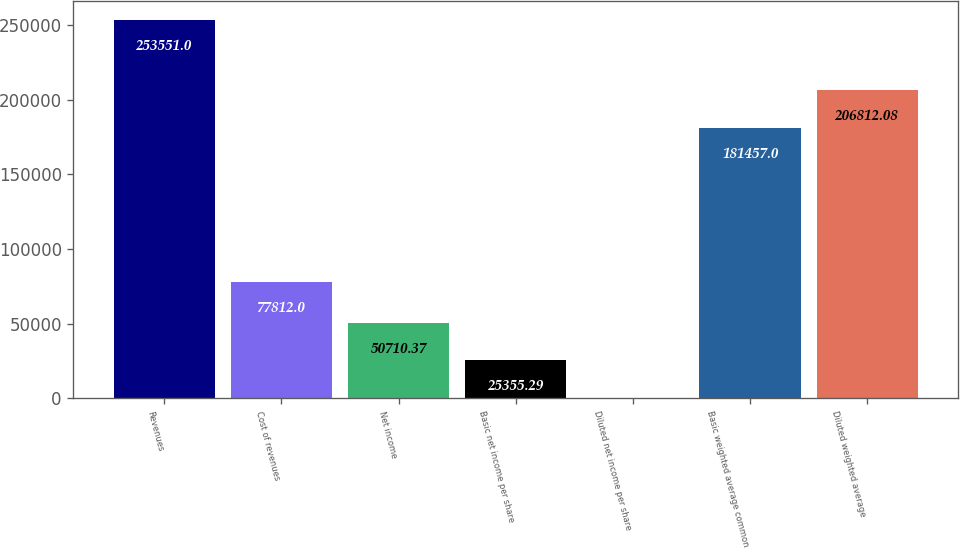Convert chart to OTSL. <chart><loc_0><loc_0><loc_500><loc_500><bar_chart><fcel>Revenues<fcel>Cost of revenues<fcel>Net income<fcel>Basic net income per share<fcel>Diluted net income per share<fcel>Basic weighted average common<fcel>Diluted weighted average<nl><fcel>253551<fcel>77812<fcel>50710.4<fcel>25355.3<fcel>0.21<fcel>181457<fcel>206812<nl></chart> 